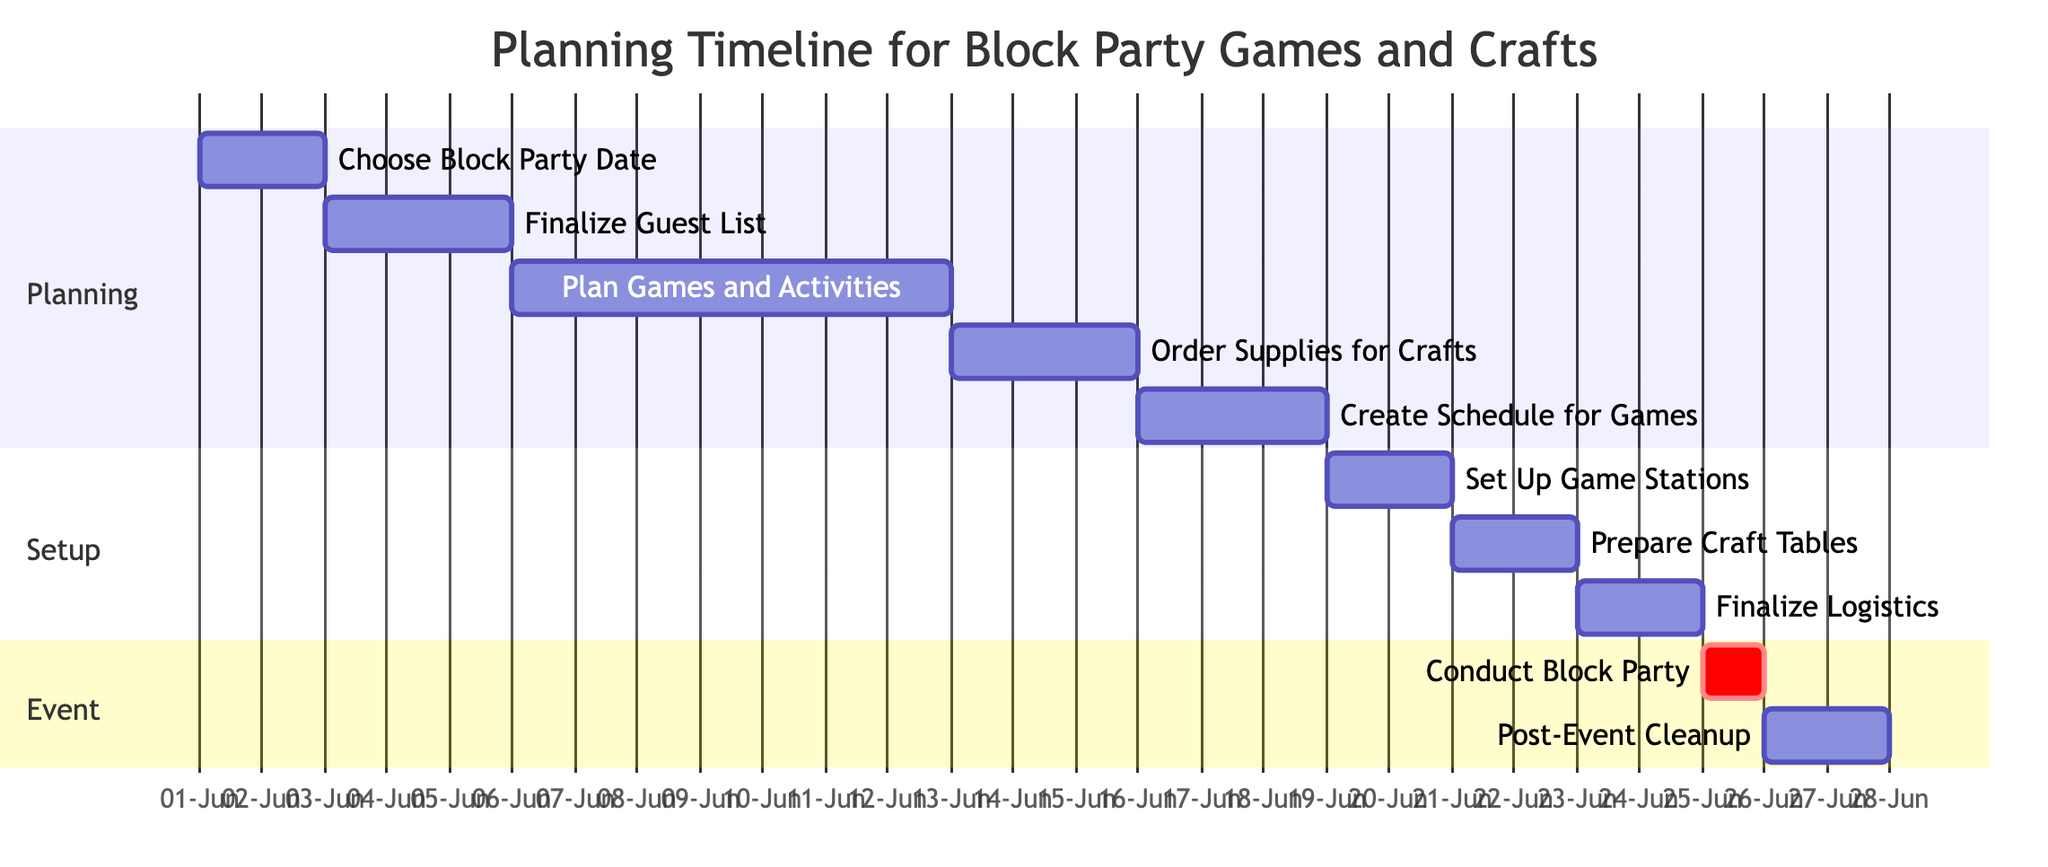What's the total number of tasks in the Gantt chart? There are 10 tasks listed in the Gantt chart, each representing a specific step in the planning and execution of the block party.
Answer: 10 What is the duration of the task "Plan Games and Activities"? The duration for "Plan Games and Activities" is 7 days, as indicated in the chart which shows the time span from June 6 to June 12, 2023.
Answer: 7 days Which task starts immediately after "Finalize Guest List"? "Plan Games and Activities" starts on June 6, which is the day after "Finalize Guest List" ends on June 5.
Answer: Plan Games and Activities What is the end date of the "Conduct Block Party" task? The task "Conduct Block Party" is scheduled to end on the same day it starts, which is June 25, 2023.
Answer: June 25 How many days are allocated for "Post-Event Cleanup"? "Post-Event Cleanup" is allocated 2 days, running from June 26 to June 27, 2023.
Answer: 2 days What task is scheduled right before "Set Up Game Stations"? "Create Schedule for Games" is scheduled to finish on June 18, which is right before "Set Up Game Stations" starts on June 19.
Answer: Create Schedule for Games When does the "Order Supplies for Crafts" task begin? The "Order Supplies for Crafts" task begins on June 13, 2023, as shown in the timeline for the planning phase.
Answer: June 13 What is the sequence of tasks leading up to the block party? The sequence is: Choose Block Party Date, Finalize Guest List, Plan Games and Activities, Order Supplies for Crafts, Create Schedule for Games, Set Up Game Stations, Finalize Logistics, Conduct Block Party.
Answer: Choose Block Party Date, Finalize Guest List, Plan Games and Activities, Order Supplies for Crafts, Create Schedule for Games, Set Up Game Stations, Finalize Logistics, Conduct Block Party What are the tasks categorized under the "Setup" section? The tasks categorized under the "Setup" section are "Set Up Game Stations", "Prepare Craft Tables", and "Finalize Logistics".
Answer: Set Up Game Stations, Prepare Craft Tables, Finalize Logistics 